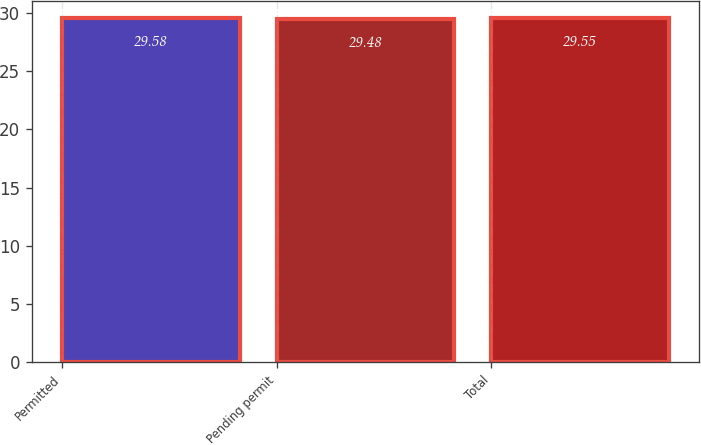Convert chart to OTSL. <chart><loc_0><loc_0><loc_500><loc_500><bar_chart><fcel>Permitted<fcel>Pending permit<fcel>Total<nl><fcel>29.58<fcel>29.48<fcel>29.55<nl></chart> 